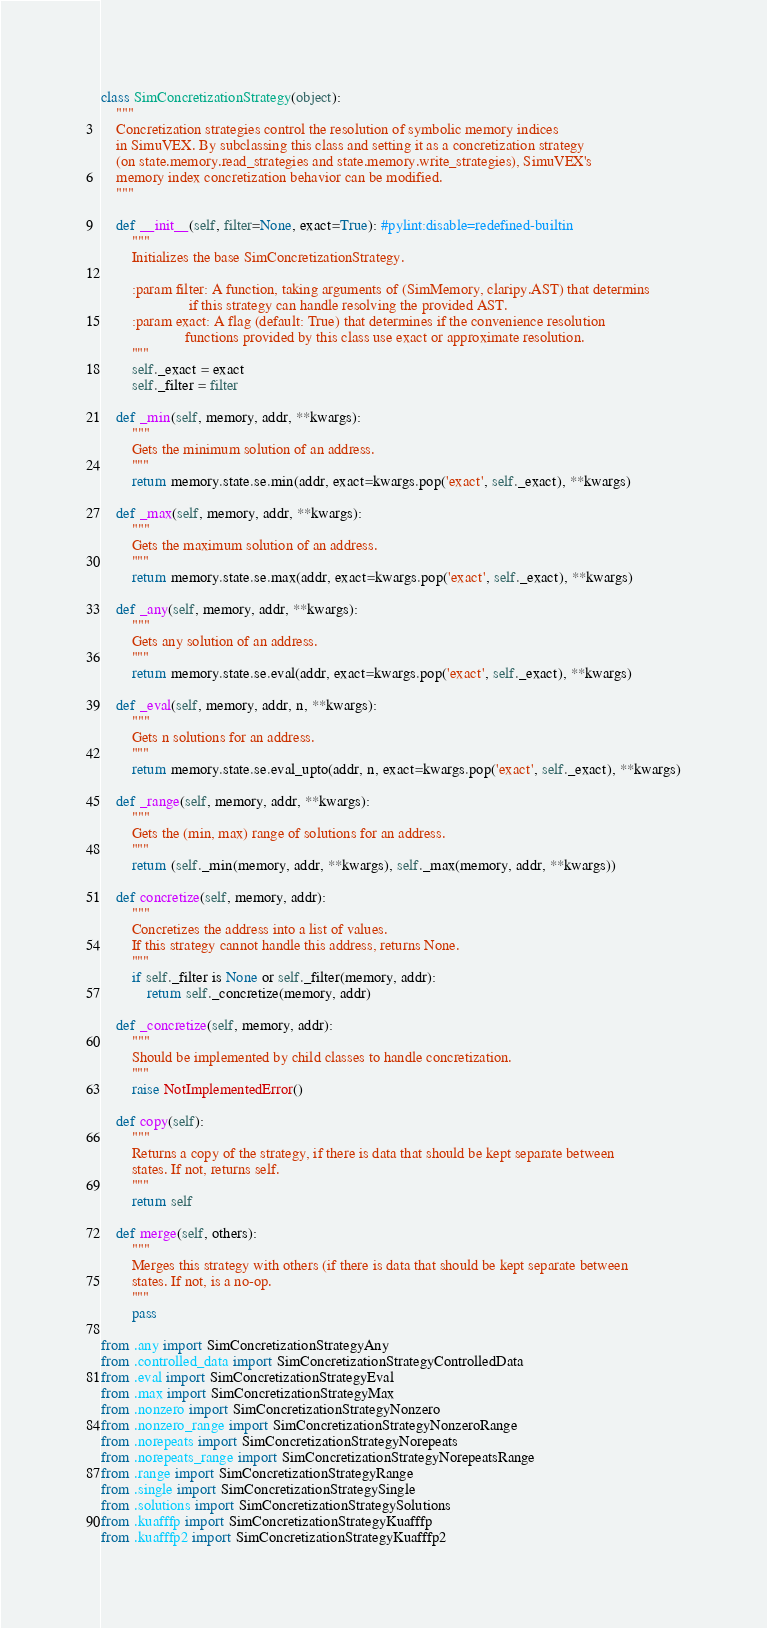Convert code to text. <code><loc_0><loc_0><loc_500><loc_500><_Python_>class SimConcretizationStrategy(object):
    """
    Concretization strategies control the resolution of symbolic memory indices
    in SimuVEX. By subclassing this class and setting it as a concretization strategy
    (on state.memory.read_strategies and state.memory.write_strategies), SimuVEX's
    memory index concretization behavior can be modified.
    """

    def __init__(self, filter=None, exact=True): #pylint:disable=redefined-builtin
        """
        Initializes the base SimConcretizationStrategy.

        :param filter: A function, taking arguments of (SimMemory, claripy.AST) that determins
                       if this strategy can handle resolving the provided AST.
        :param exact: A flag (default: True) that determines if the convenience resolution
                      functions provided by this class use exact or approximate resolution.
        """
        self._exact = exact
        self._filter = filter

    def _min(self, memory, addr, **kwargs):
        """
        Gets the minimum solution of an address.
        """
        return memory.state.se.min(addr, exact=kwargs.pop('exact', self._exact), **kwargs)

    def _max(self, memory, addr, **kwargs):
        """
        Gets the maximum solution of an address.
        """
        return memory.state.se.max(addr, exact=kwargs.pop('exact', self._exact), **kwargs)

    def _any(self, memory, addr, **kwargs):
        """
        Gets any solution of an address.
        """
        return memory.state.se.eval(addr, exact=kwargs.pop('exact', self._exact), **kwargs)

    def _eval(self, memory, addr, n, **kwargs):
        """
        Gets n solutions for an address.
        """
        return memory.state.se.eval_upto(addr, n, exact=kwargs.pop('exact', self._exact), **kwargs)

    def _range(self, memory, addr, **kwargs):
        """
        Gets the (min, max) range of solutions for an address.
        """
        return (self._min(memory, addr, **kwargs), self._max(memory, addr, **kwargs))

    def concretize(self, memory, addr):
        """
        Concretizes the address into a list of values.
        If this strategy cannot handle this address, returns None.
        """
        if self._filter is None or self._filter(memory, addr):
            return self._concretize(memory, addr)

    def _concretize(self, memory, addr):
        """
        Should be implemented by child classes to handle concretization.
        """
        raise NotImplementedError()

    def copy(self):
        """
        Returns a copy of the strategy, if there is data that should be kept separate between
        states. If not, returns self.
        """
        return self

    def merge(self, others):
        """
        Merges this strategy with others (if there is data that should be kept separate between
        states. If not, is a no-op.
        """
        pass

from .any import SimConcretizationStrategyAny
from .controlled_data import SimConcretizationStrategyControlledData
from .eval import SimConcretizationStrategyEval
from .max import SimConcretizationStrategyMax
from .nonzero import SimConcretizationStrategyNonzero
from .nonzero_range import SimConcretizationStrategyNonzeroRange
from .norepeats import SimConcretizationStrategyNorepeats
from .norepeats_range import SimConcretizationStrategyNorepeatsRange
from .range import SimConcretizationStrategyRange
from .single import SimConcretizationStrategySingle
from .solutions import SimConcretizationStrategySolutions
from .kuafffp import SimConcretizationStrategyKuafffp
from .kuafffp2 import SimConcretizationStrategyKuafffp2
</code> 